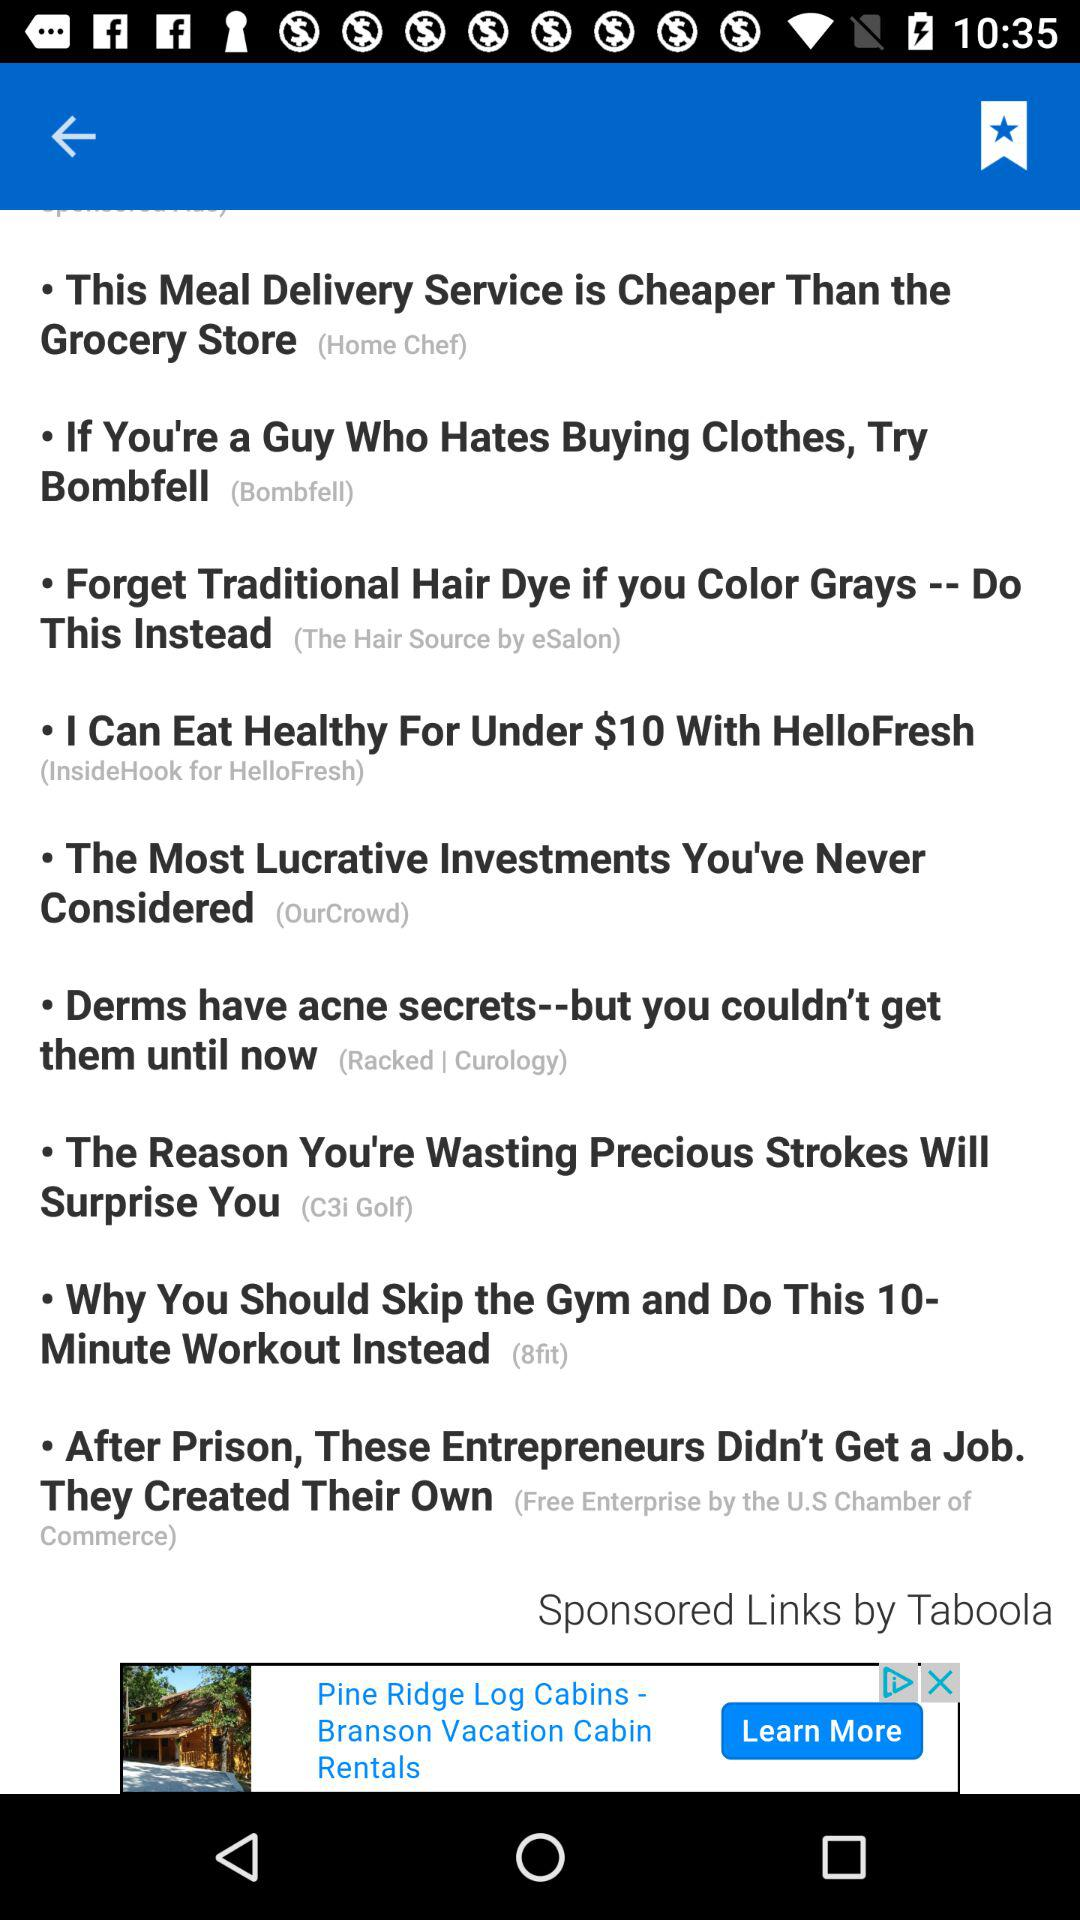Where can I eat healthy for under $10? You can eat healthy for under $10 with "HelloFresh". 